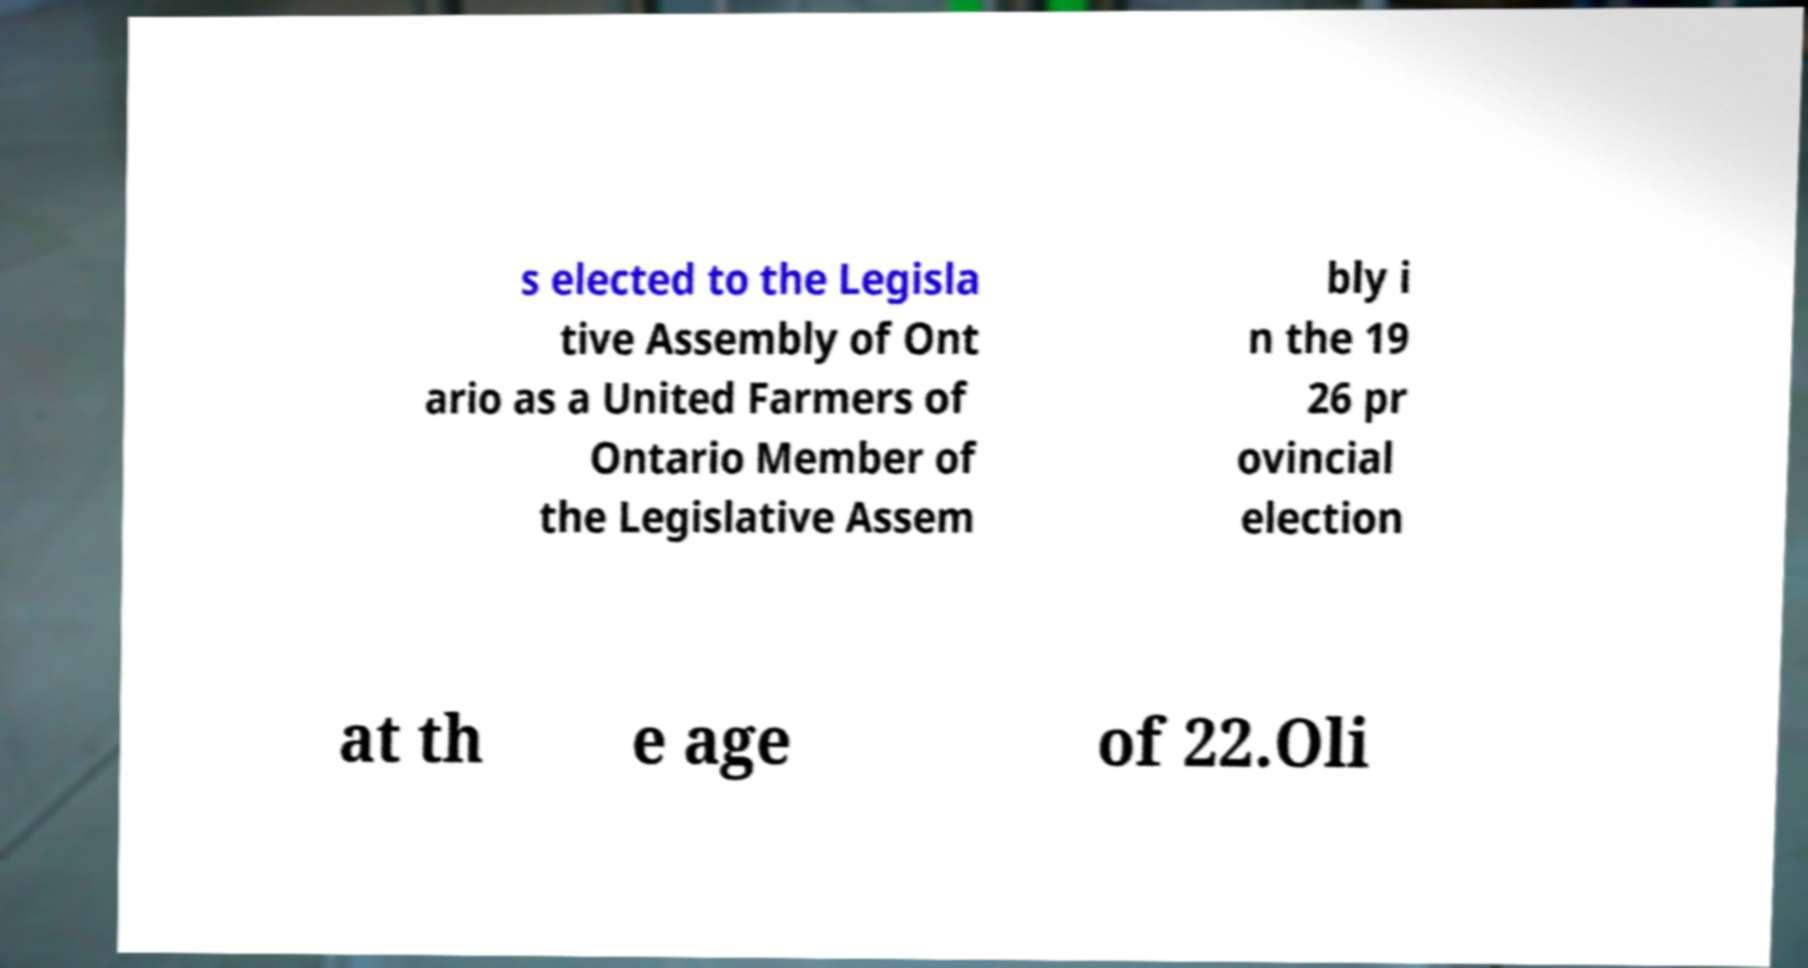Please read and relay the text visible in this image. What does it say? s elected to the Legisla tive Assembly of Ont ario as a United Farmers of Ontario Member of the Legislative Assem bly i n the 19 26 pr ovincial election at th e age of 22.Oli 